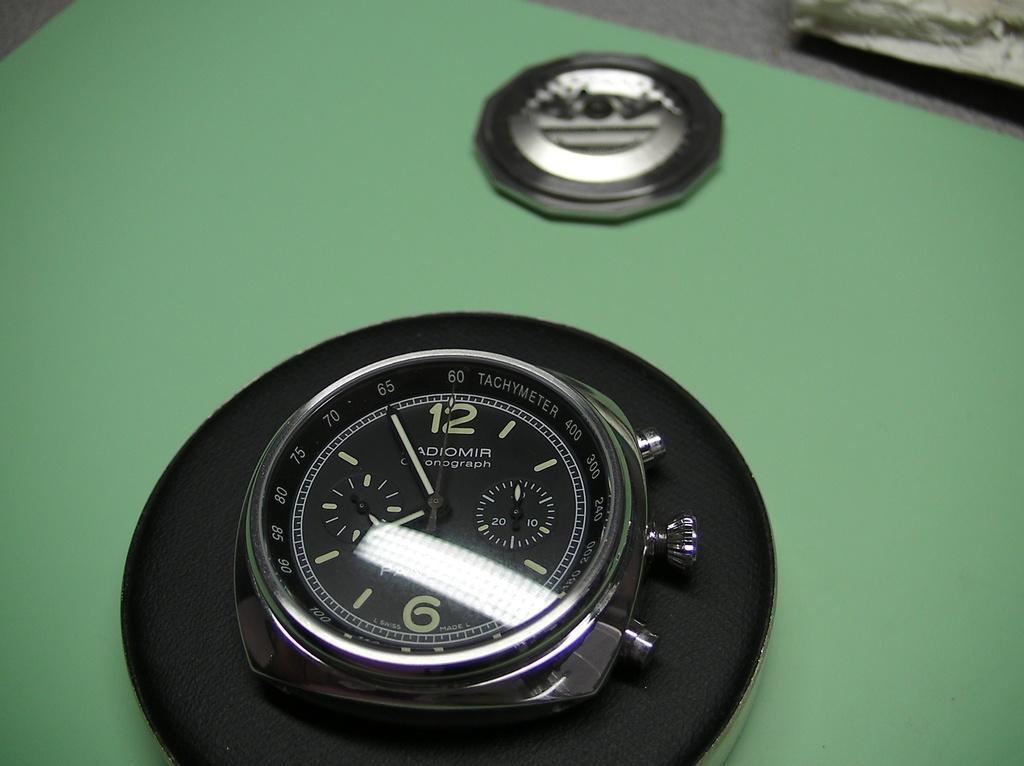What time is it?
Provide a succinct answer. 7:55. What is the bottom number?
Your answer should be very brief. 6. 